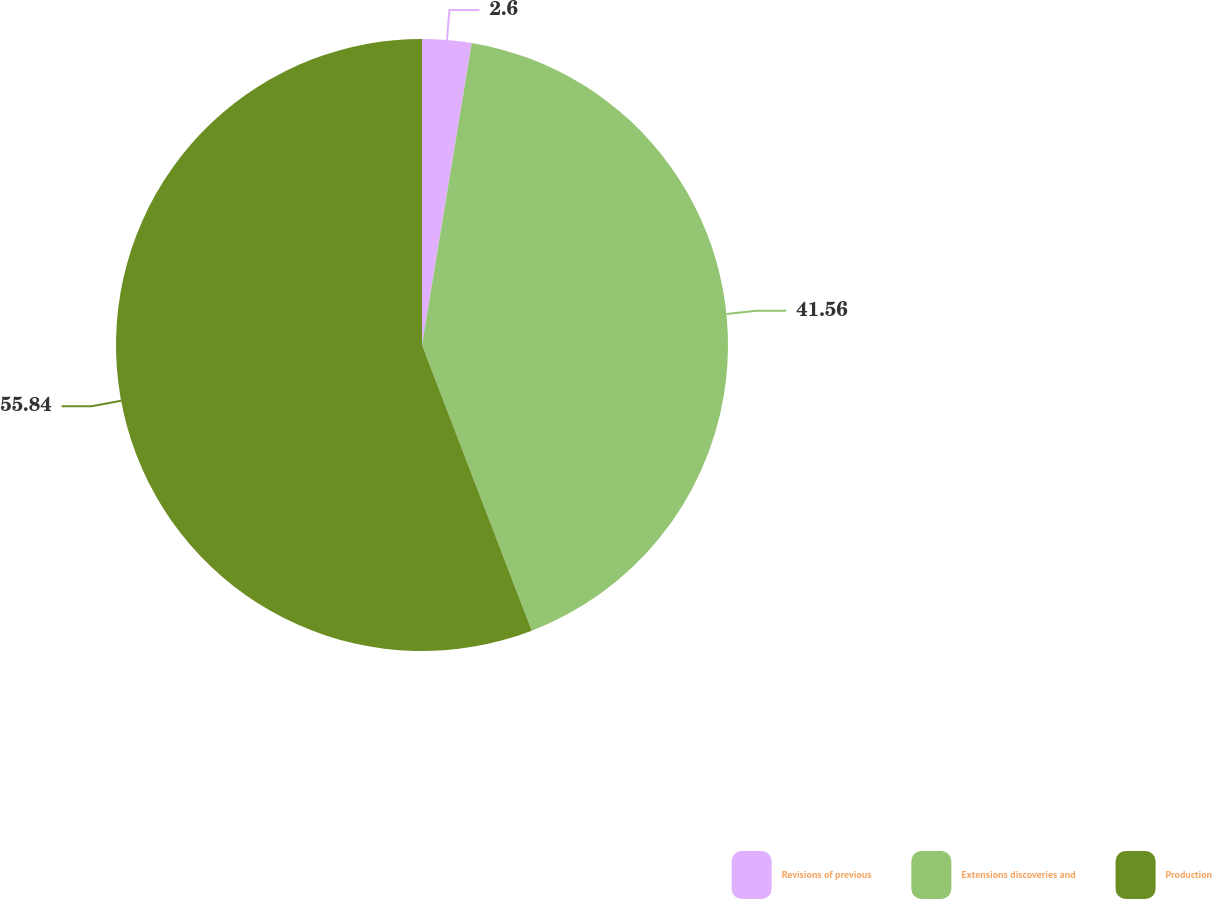<chart> <loc_0><loc_0><loc_500><loc_500><pie_chart><fcel>Revisions of previous<fcel>Extensions discoveries and<fcel>Production<nl><fcel>2.6%<fcel>41.56%<fcel>55.84%<nl></chart> 